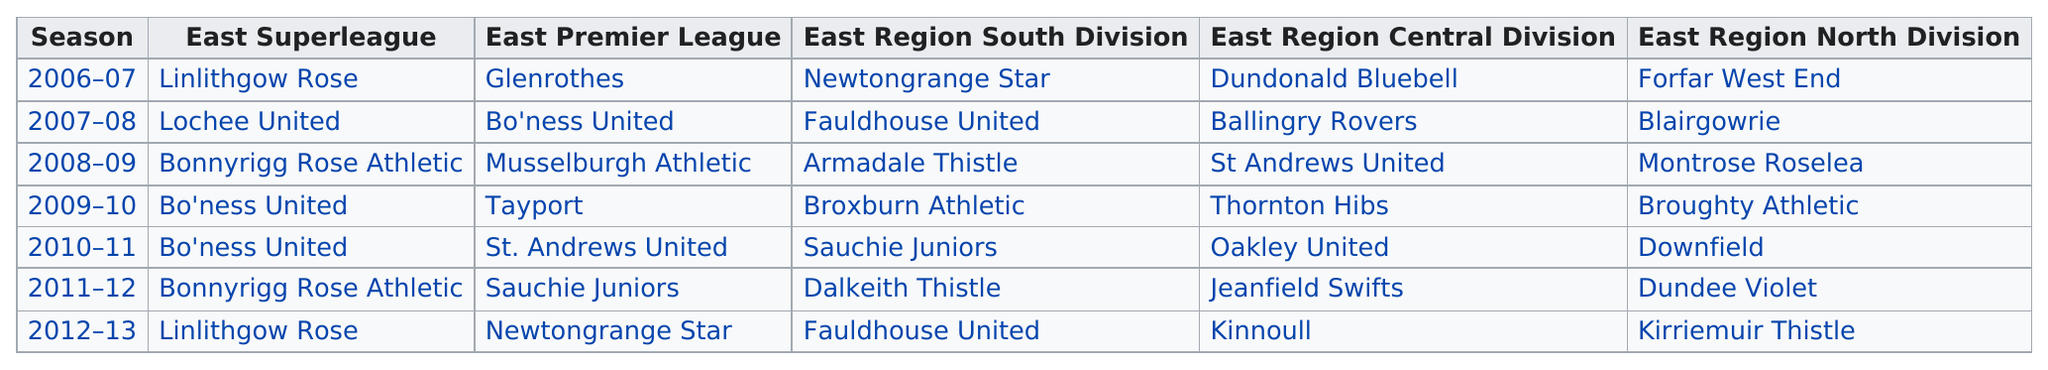Indicate a few pertinent items in this graphic. There are 1 year in a season. After the 2006 to 2008 season, Bonnyrigg Rose Athletic was a team in the East Superleague. Bo'ness United won the East Superleague for the first time in the 2009-2010 season. In the East Region South Division, Fauldhouse United has achieved the greatest number of victories, making the roll of honor more times than Newtongrange Star. There are fewer than 14 teams in the column of the East Superleague, resulting in a negative response. 